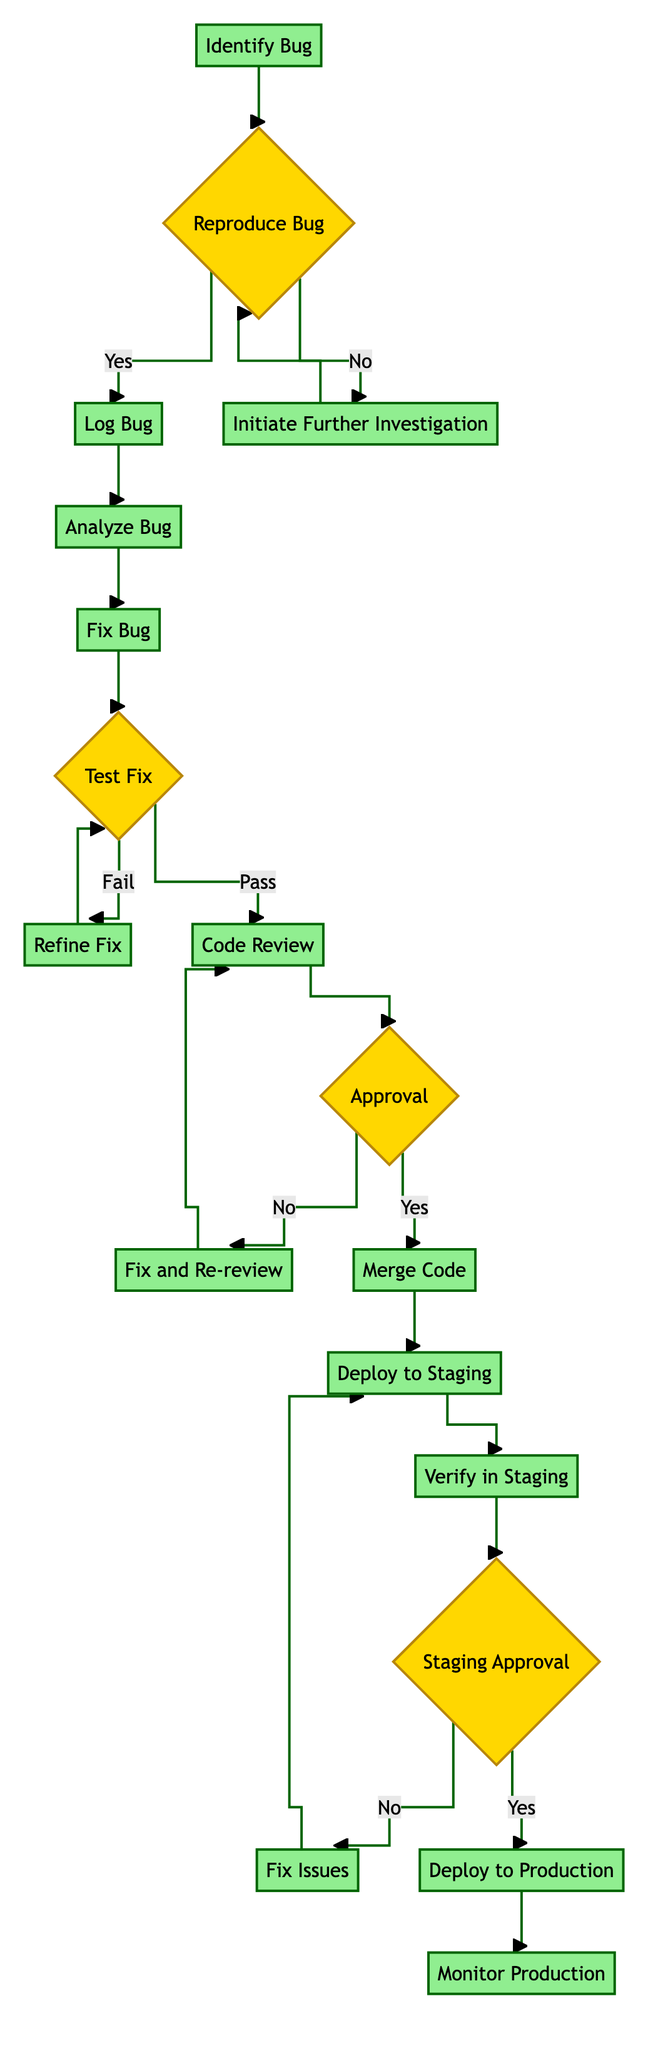What is the first activity in the process? The diagram begins with the activity labeled "Identify Bug." This is shown as the starting point at the top of the flow.
Answer: Identify Bug How many decision points are in the diagram? By counting the decision nodes marked with curly braces, we find four decision points (Reproduce Bug, Test Fix, Approval, Staging Approval).
Answer: 4 What happens if the bug cannot be reproduced? If the bug cannot be reproduced, the flow goes to "Initiate Further Investigation" to gather more data. This is shown to the right of the decision node "Reproduce Bug."
Answer: Initiate Further Investigation Which activity follows "Fix Bug" if the tests pass? If the tests pass after fixing the bug, the next activity in the flow is "Code Review." This can be traced from the decision node "Test Fix," where the "Pass" path leads to "Code Review."
Answer: Code Review What is the final activity in the process? The last activity in the flow is "Monitor Production," which occurs after the "Deploy to Production." This is clearly positioned at the end of the flow diagram.
Answer: Monitor Production What action occurs if the staging is not approved? If the staging is not approved, the process flows to "Fix Issues," which is shown to the left of the decision point "Staging Approval." This leads to resolving issues before redeploying.
Answer: Fix Issues What must happen after a code review if the changes are not approved? If the changes from the code review are not approved, the next action is "Fix and Re-review," which directs back to start another round of the code review process.
Answer: Fix and Re-review Which activity comes after "Verify in Staging"? The activity that follows "Verify in Staging" is the decision point "Staging Approval," as depicted in the flow after these actions.
Answer: Staging Approval 